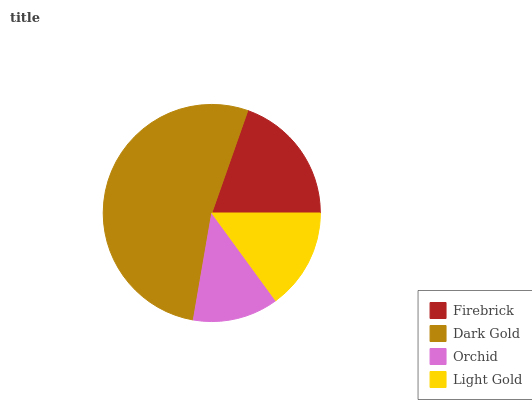Is Orchid the minimum?
Answer yes or no. Yes. Is Dark Gold the maximum?
Answer yes or no. Yes. Is Dark Gold the minimum?
Answer yes or no. No. Is Orchid the maximum?
Answer yes or no. No. Is Dark Gold greater than Orchid?
Answer yes or no. Yes. Is Orchid less than Dark Gold?
Answer yes or no. Yes. Is Orchid greater than Dark Gold?
Answer yes or no. No. Is Dark Gold less than Orchid?
Answer yes or no. No. Is Firebrick the high median?
Answer yes or no. Yes. Is Light Gold the low median?
Answer yes or no. Yes. Is Orchid the high median?
Answer yes or no. No. Is Orchid the low median?
Answer yes or no. No. 